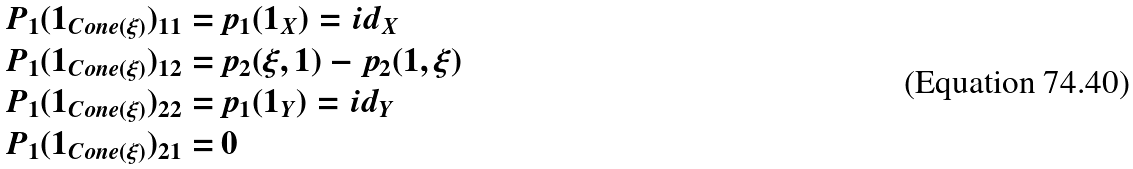<formula> <loc_0><loc_0><loc_500><loc_500>P _ { 1 } ( 1 _ { C o n e ( \xi ) } ) _ { 1 1 } = & \, p _ { 1 } ( 1 _ { X } ) = i d _ { X } \\ P _ { 1 } ( 1 _ { C o n e ( \xi ) } ) _ { 1 2 } = & \, p _ { 2 } ( \xi , 1 ) - p _ { 2 } ( 1 , \xi ) \\ P _ { 1 } ( 1 _ { C o n e ( \xi ) } ) _ { 2 2 } = & \, p _ { 1 } ( 1 _ { Y } ) = i d _ { Y } \\ P _ { 1 } ( 1 _ { C o n e ( \xi ) } ) _ { 2 1 } = & \, 0</formula> 